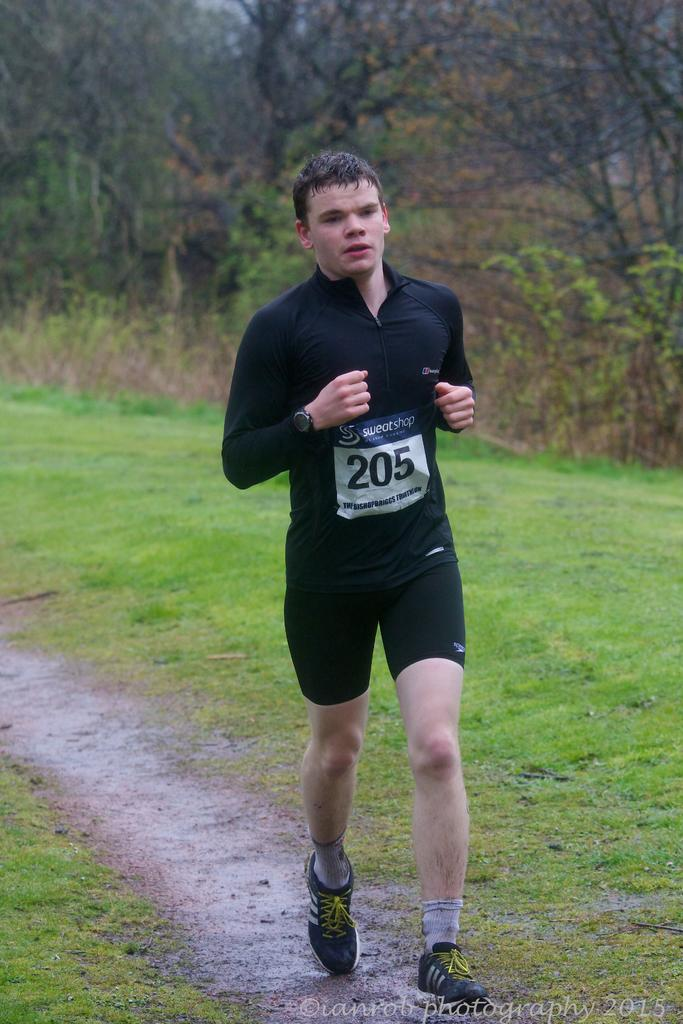What is the person in the image doing? The person is running in the image. Where is the person running? The person is running on a path. What can be seen in the background of the image? There are plants, trees, and grassland visible in the background of the image. What page of the book is the person reading while running in the image? There is no book or reading activity present in the image; the person is running. 